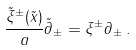<formula> <loc_0><loc_0><loc_500><loc_500>\frac { \tilde { \xi } ^ { \pm } ( \tilde { x } ) } { a } \tilde { \partial } _ { \pm } = \xi ^ { \pm } \partial _ { \pm } \, .</formula> 